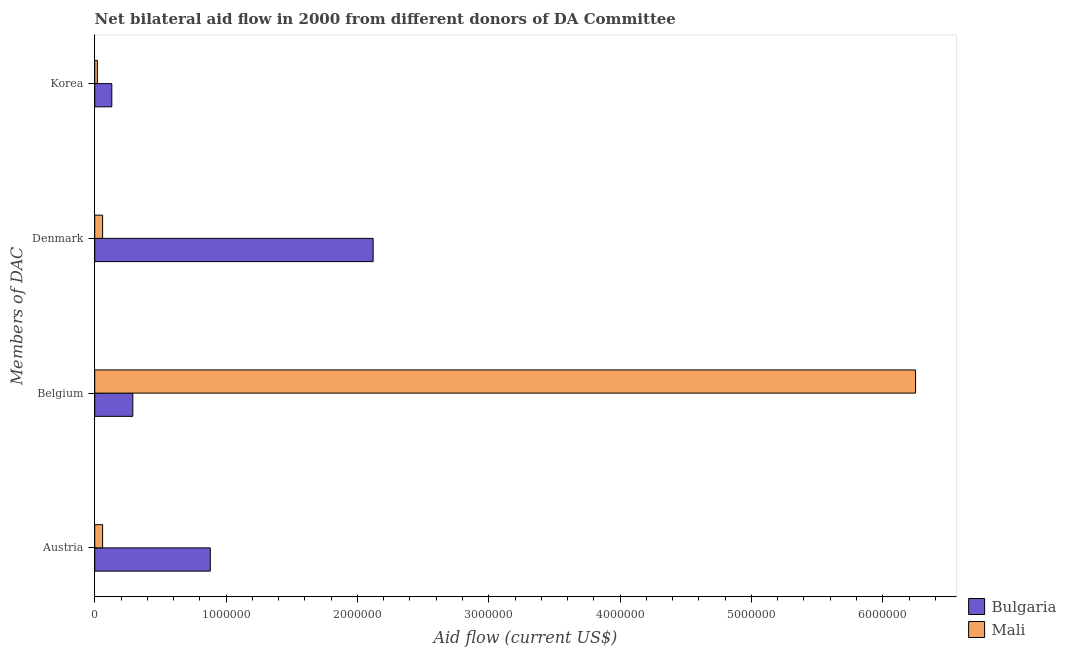How many different coloured bars are there?
Your answer should be very brief. 2. How many groups of bars are there?
Offer a very short reply. 4. How many bars are there on the 2nd tick from the bottom?
Provide a short and direct response. 2. What is the amount of aid given by korea in Bulgaria?
Your answer should be compact. 1.30e+05. Across all countries, what is the maximum amount of aid given by korea?
Offer a terse response. 1.30e+05. Across all countries, what is the minimum amount of aid given by korea?
Offer a terse response. 2.00e+04. In which country was the amount of aid given by denmark minimum?
Give a very brief answer. Mali. What is the total amount of aid given by korea in the graph?
Offer a very short reply. 1.50e+05. What is the difference between the amount of aid given by belgium in Bulgaria and that in Mali?
Offer a very short reply. -5.96e+06. What is the difference between the amount of aid given by belgium in Mali and the amount of aid given by denmark in Bulgaria?
Keep it short and to the point. 4.13e+06. What is the average amount of aid given by korea per country?
Provide a short and direct response. 7.50e+04. What is the difference between the amount of aid given by belgium and amount of aid given by denmark in Mali?
Keep it short and to the point. 6.19e+06. In how many countries, is the amount of aid given by korea greater than 2800000 US$?
Ensure brevity in your answer.  0. What is the ratio of the amount of aid given by denmark in Mali to that in Bulgaria?
Your response must be concise. 0.03. Is the difference between the amount of aid given by austria in Mali and Bulgaria greater than the difference between the amount of aid given by belgium in Mali and Bulgaria?
Provide a short and direct response. No. What is the difference between the highest and the second highest amount of aid given by austria?
Make the answer very short. 8.20e+05. What is the difference between the highest and the lowest amount of aid given by denmark?
Your answer should be very brief. 2.06e+06. Is the sum of the amount of aid given by denmark in Bulgaria and Mali greater than the maximum amount of aid given by austria across all countries?
Keep it short and to the point. Yes. What does the 2nd bar from the top in Austria represents?
Your answer should be very brief. Bulgaria. What does the 2nd bar from the bottom in Korea represents?
Your answer should be compact. Mali. Is it the case that in every country, the sum of the amount of aid given by austria and amount of aid given by belgium is greater than the amount of aid given by denmark?
Offer a terse response. No. What is the difference between two consecutive major ticks on the X-axis?
Offer a very short reply. 1.00e+06. How are the legend labels stacked?
Your response must be concise. Vertical. What is the title of the graph?
Offer a terse response. Net bilateral aid flow in 2000 from different donors of DA Committee. What is the label or title of the Y-axis?
Ensure brevity in your answer.  Members of DAC. What is the Aid flow (current US$) in Bulgaria in Austria?
Provide a short and direct response. 8.80e+05. What is the Aid flow (current US$) in Mali in Austria?
Provide a short and direct response. 6.00e+04. What is the Aid flow (current US$) in Bulgaria in Belgium?
Your response must be concise. 2.90e+05. What is the Aid flow (current US$) in Mali in Belgium?
Offer a very short reply. 6.25e+06. What is the Aid flow (current US$) of Bulgaria in Denmark?
Give a very brief answer. 2.12e+06. What is the Aid flow (current US$) in Mali in Denmark?
Your response must be concise. 6.00e+04. Across all Members of DAC, what is the maximum Aid flow (current US$) of Bulgaria?
Provide a short and direct response. 2.12e+06. Across all Members of DAC, what is the maximum Aid flow (current US$) of Mali?
Provide a short and direct response. 6.25e+06. Across all Members of DAC, what is the minimum Aid flow (current US$) of Mali?
Your answer should be compact. 2.00e+04. What is the total Aid flow (current US$) in Bulgaria in the graph?
Your answer should be compact. 3.42e+06. What is the total Aid flow (current US$) in Mali in the graph?
Keep it short and to the point. 6.39e+06. What is the difference between the Aid flow (current US$) of Bulgaria in Austria and that in Belgium?
Provide a succinct answer. 5.90e+05. What is the difference between the Aid flow (current US$) in Mali in Austria and that in Belgium?
Your answer should be very brief. -6.19e+06. What is the difference between the Aid flow (current US$) of Bulgaria in Austria and that in Denmark?
Provide a succinct answer. -1.24e+06. What is the difference between the Aid flow (current US$) in Mali in Austria and that in Denmark?
Make the answer very short. 0. What is the difference between the Aid flow (current US$) in Bulgaria in Austria and that in Korea?
Offer a very short reply. 7.50e+05. What is the difference between the Aid flow (current US$) in Mali in Austria and that in Korea?
Provide a succinct answer. 4.00e+04. What is the difference between the Aid flow (current US$) of Bulgaria in Belgium and that in Denmark?
Keep it short and to the point. -1.83e+06. What is the difference between the Aid flow (current US$) in Mali in Belgium and that in Denmark?
Keep it short and to the point. 6.19e+06. What is the difference between the Aid flow (current US$) of Mali in Belgium and that in Korea?
Your answer should be very brief. 6.23e+06. What is the difference between the Aid flow (current US$) of Bulgaria in Denmark and that in Korea?
Keep it short and to the point. 1.99e+06. What is the difference between the Aid flow (current US$) in Bulgaria in Austria and the Aid flow (current US$) in Mali in Belgium?
Keep it short and to the point. -5.37e+06. What is the difference between the Aid flow (current US$) of Bulgaria in Austria and the Aid flow (current US$) of Mali in Denmark?
Make the answer very short. 8.20e+05. What is the difference between the Aid flow (current US$) in Bulgaria in Austria and the Aid flow (current US$) in Mali in Korea?
Your answer should be very brief. 8.60e+05. What is the difference between the Aid flow (current US$) in Bulgaria in Denmark and the Aid flow (current US$) in Mali in Korea?
Offer a very short reply. 2.10e+06. What is the average Aid flow (current US$) of Bulgaria per Members of DAC?
Your answer should be compact. 8.55e+05. What is the average Aid flow (current US$) in Mali per Members of DAC?
Keep it short and to the point. 1.60e+06. What is the difference between the Aid flow (current US$) of Bulgaria and Aid flow (current US$) of Mali in Austria?
Offer a very short reply. 8.20e+05. What is the difference between the Aid flow (current US$) in Bulgaria and Aid flow (current US$) in Mali in Belgium?
Your answer should be compact. -5.96e+06. What is the difference between the Aid flow (current US$) of Bulgaria and Aid flow (current US$) of Mali in Denmark?
Ensure brevity in your answer.  2.06e+06. What is the difference between the Aid flow (current US$) of Bulgaria and Aid flow (current US$) of Mali in Korea?
Your response must be concise. 1.10e+05. What is the ratio of the Aid flow (current US$) in Bulgaria in Austria to that in Belgium?
Your response must be concise. 3.03. What is the ratio of the Aid flow (current US$) of Mali in Austria to that in Belgium?
Keep it short and to the point. 0.01. What is the ratio of the Aid flow (current US$) in Bulgaria in Austria to that in Denmark?
Offer a very short reply. 0.42. What is the ratio of the Aid flow (current US$) of Mali in Austria to that in Denmark?
Keep it short and to the point. 1. What is the ratio of the Aid flow (current US$) in Bulgaria in Austria to that in Korea?
Make the answer very short. 6.77. What is the ratio of the Aid flow (current US$) of Mali in Austria to that in Korea?
Offer a terse response. 3. What is the ratio of the Aid flow (current US$) of Bulgaria in Belgium to that in Denmark?
Offer a terse response. 0.14. What is the ratio of the Aid flow (current US$) in Mali in Belgium to that in Denmark?
Keep it short and to the point. 104.17. What is the ratio of the Aid flow (current US$) in Bulgaria in Belgium to that in Korea?
Your answer should be very brief. 2.23. What is the ratio of the Aid flow (current US$) of Mali in Belgium to that in Korea?
Make the answer very short. 312.5. What is the ratio of the Aid flow (current US$) of Bulgaria in Denmark to that in Korea?
Provide a succinct answer. 16.31. What is the ratio of the Aid flow (current US$) in Mali in Denmark to that in Korea?
Offer a very short reply. 3. What is the difference between the highest and the second highest Aid flow (current US$) of Bulgaria?
Give a very brief answer. 1.24e+06. What is the difference between the highest and the second highest Aid flow (current US$) of Mali?
Your response must be concise. 6.19e+06. What is the difference between the highest and the lowest Aid flow (current US$) of Bulgaria?
Your answer should be very brief. 1.99e+06. What is the difference between the highest and the lowest Aid flow (current US$) in Mali?
Offer a very short reply. 6.23e+06. 